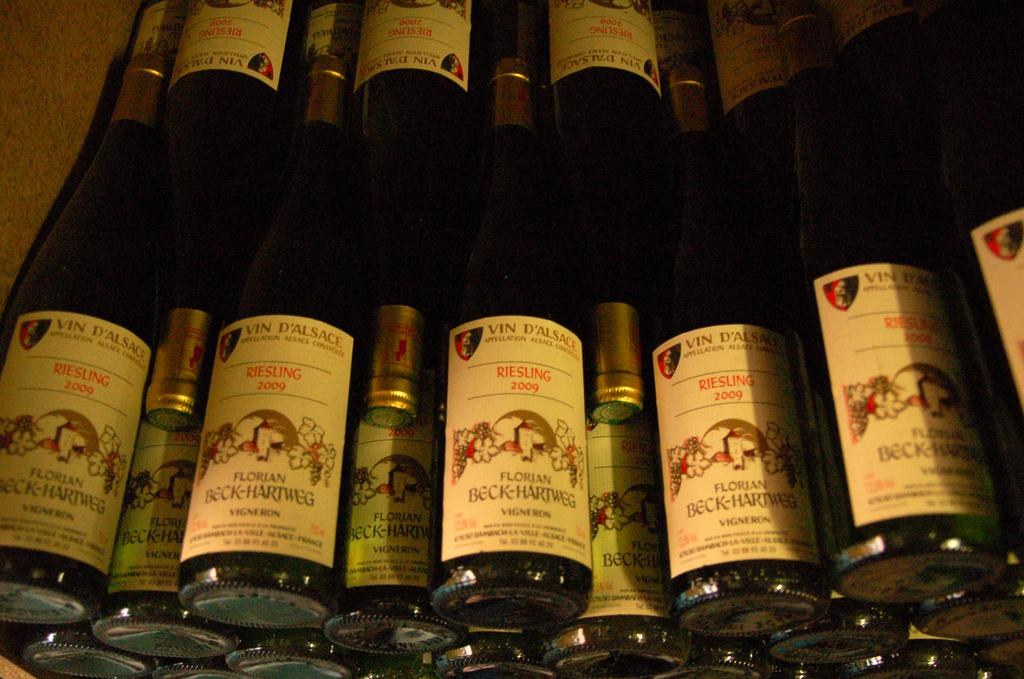<image>
Render a clear and concise summary of the photo. Many bottles of Riesling Florian alcohol stacked together. 